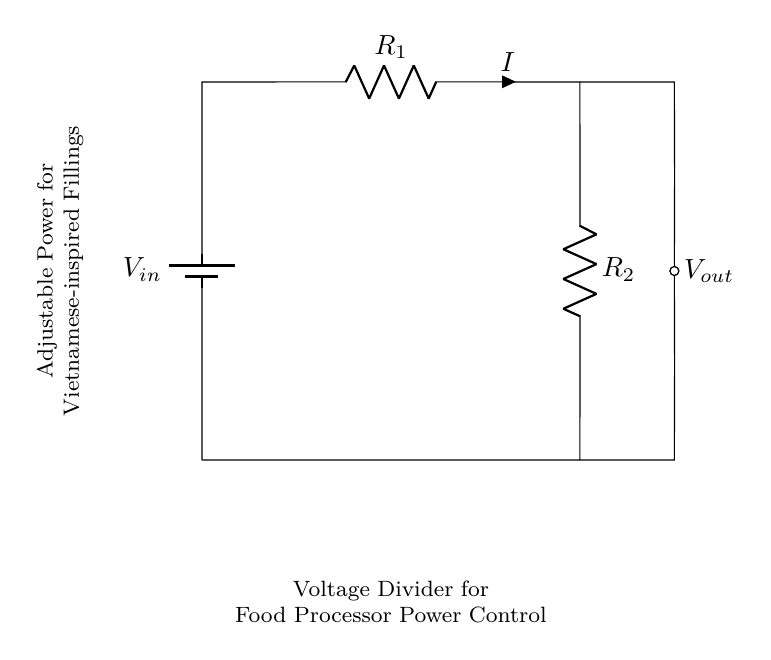What is the input voltage symbol in this circuit? The input voltage is represented as V_in, which is shown on the left side of the circuit diagram.
Answer: V_in What are the resistors labeled in this voltage divider? The resistors are labeled R_1 and R_2, with R_1 being the upper resistor connected to the input voltage and R_2 being the lower resistor connected to the ground.
Answer: R_1, R_2 What does V_out represent in this circuit? V_out is the output voltage taken from the voltage divider, indicating the voltage across R_2. It is marked on the right side of the circuit diagram.
Answer: V_out How do you calculate the output voltage of this voltage divider? The output voltage V_out can be calculated using the formula V_out = V_in * (R_2 / (R_1 + R_2)), where V_in is the input voltage, R_1 is the upper resistor, and R_2 is the lower resistor. This demonstrates the proportion of voltage drop across R_2 compared to the total resistance of R_1 and R_2.
Answer: V_out = V_in * (R_2 / (R_1 + R_2)) What is the purpose of this circuit in relation to a food processor? The circuit adjusts the power output of the food processor, allowing for fine-tuning of the machine's speed or power level based on the requirements needed for creating Vietnamese-inspired fillings. This effectively helps control the texture and consistency of the fillings.
Answer: Adjusts power output 